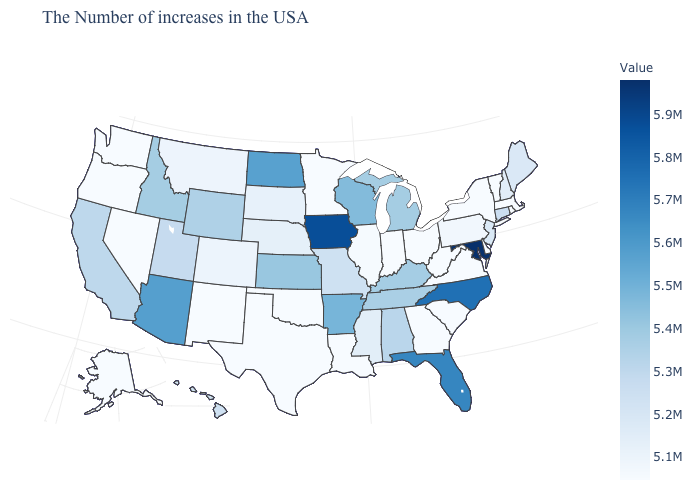Which states hav the highest value in the Northeast?
Concise answer only. Connecticut. Which states hav the highest value in the South?
Be succinct. Maryland. Does the map have missing data?
Quick response, please. No. Does the map have missing data?
Keep it brief. No. Does the map have missing data?
Keep it brief. No. Among the states that border Nevada , does Idaho have the highest value?
Answer briefly. No. 